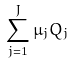Convert formula to latex. <formula><loc_0><loc_0><loc_500><loc_500>\sum _ { j = 1 } ^ { J } \mu _ { j } Q _ { j }</formula> 